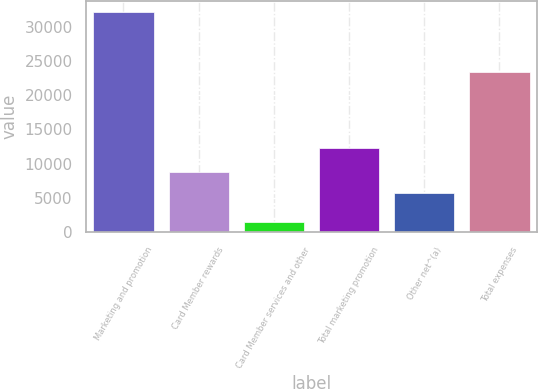<chart> <loc_0><loc_0><loc_500><loc_500><bar_chart><fcel>Marketing and promotion<fcel>Card Member rewards<fcel>Card Member services and other<fcel>Total marketing promotion<fcel>Other net^(a)<fcel>Total expenses<nl><fcel>32177<fcel>8849.8<fcel>1439<fcel>12264<fcel>5776<fcel>23298<nl></chart> 